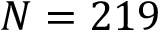<formula> <loc_0><loc_0><loc_500><loc_500>N = 2 1 9</formula> 